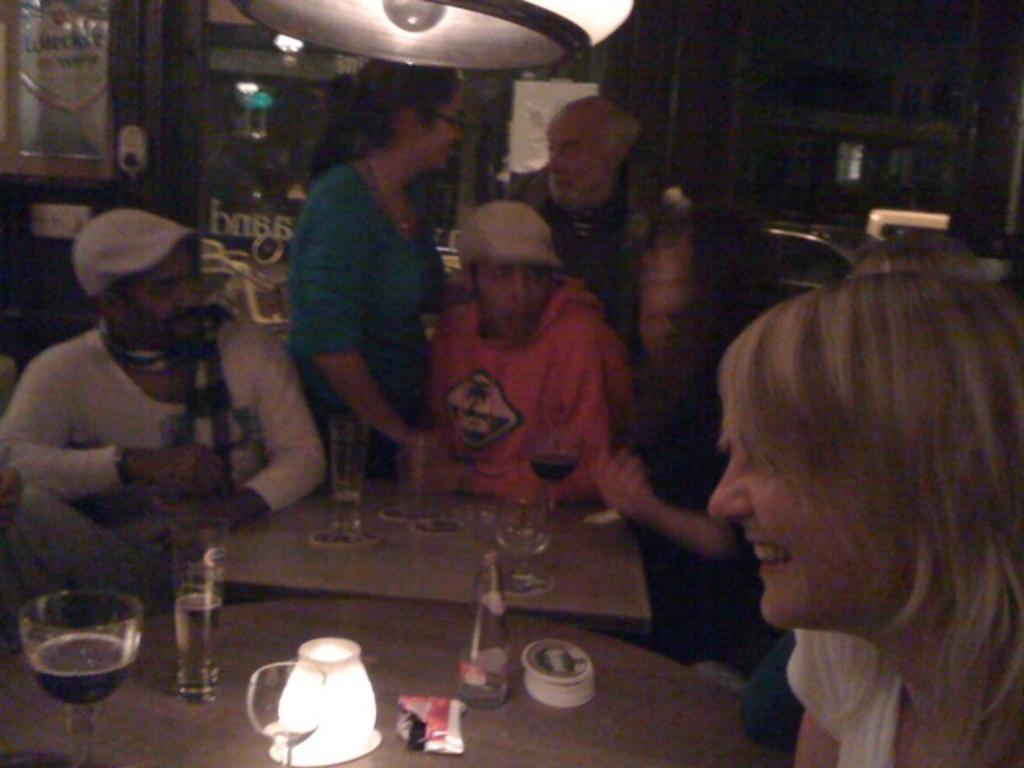Can you describe this image briefly? There are group of people sitting around the table which has glass of drinks on it and there are two people standing behind them. 